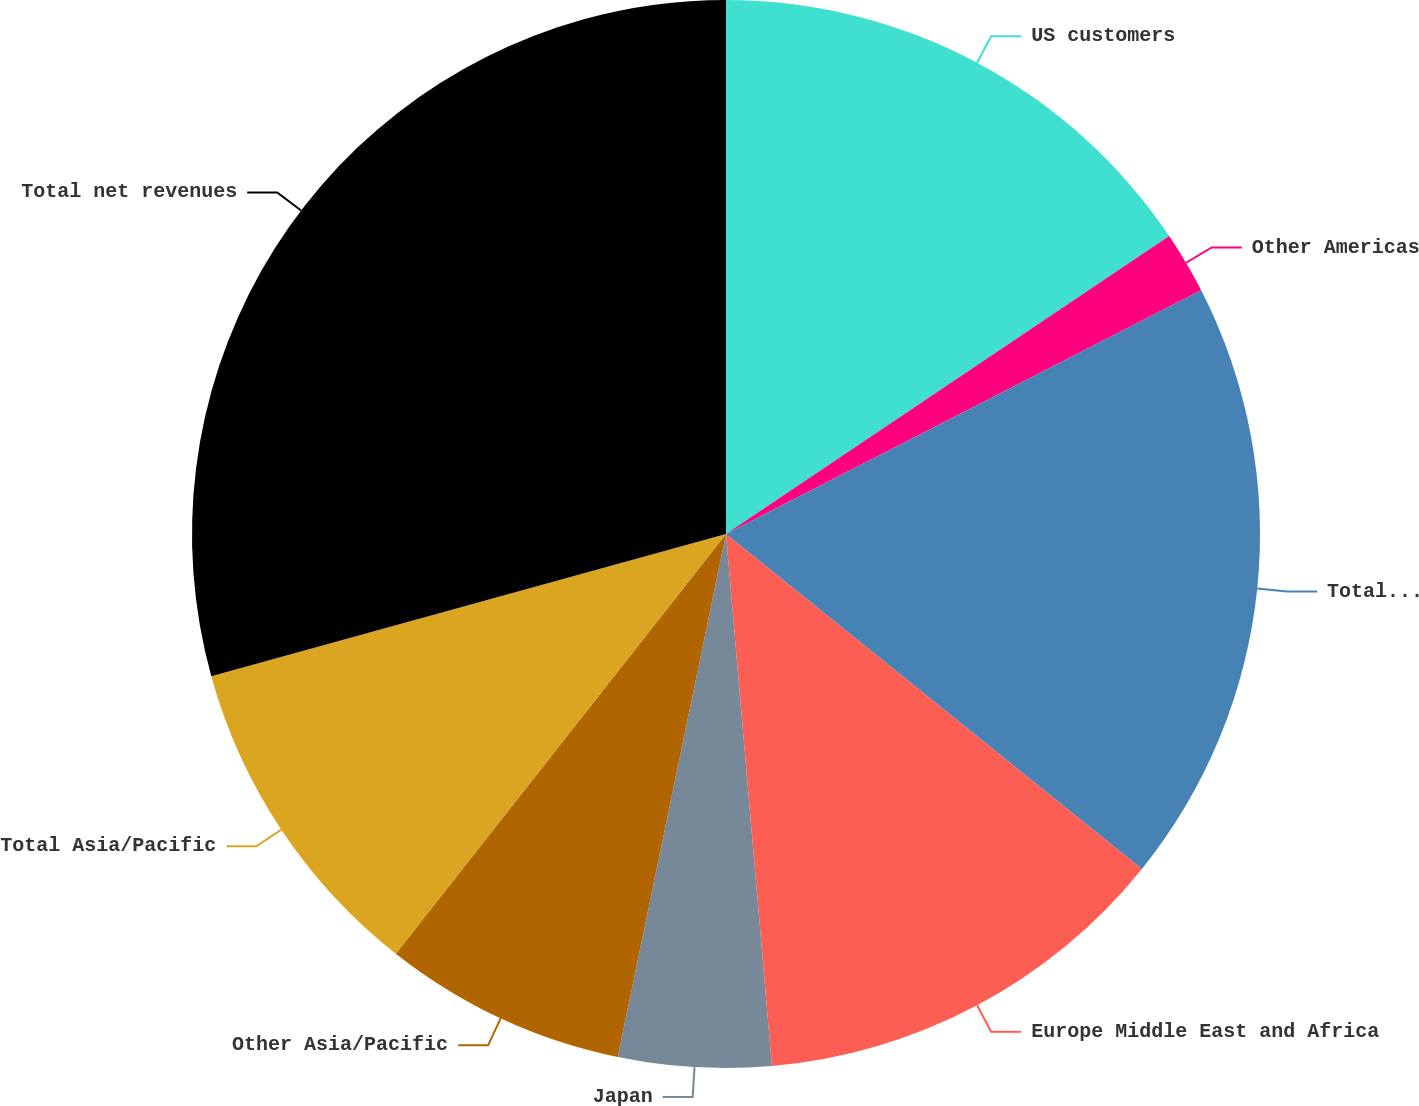<chart> <loc_0><loc_0><loc_500><loc_500><pie_chart><fcel>US customers<fcel>Other Americas<fcel>Total Americas<fcel>Europe Middle East and Africa<fcel>Japan<fcel>Other Asia/Pacific<fcel>Total Asia/Pacific<fcel>Total net revenues<nl><fcel>15.58%<fcel>1.88%<fcel>18.33%<fcel>12.84%<fcel>4.62%<fcel>7.36%<fcel>10.1%<fcel>29.29%<nl></chart> 